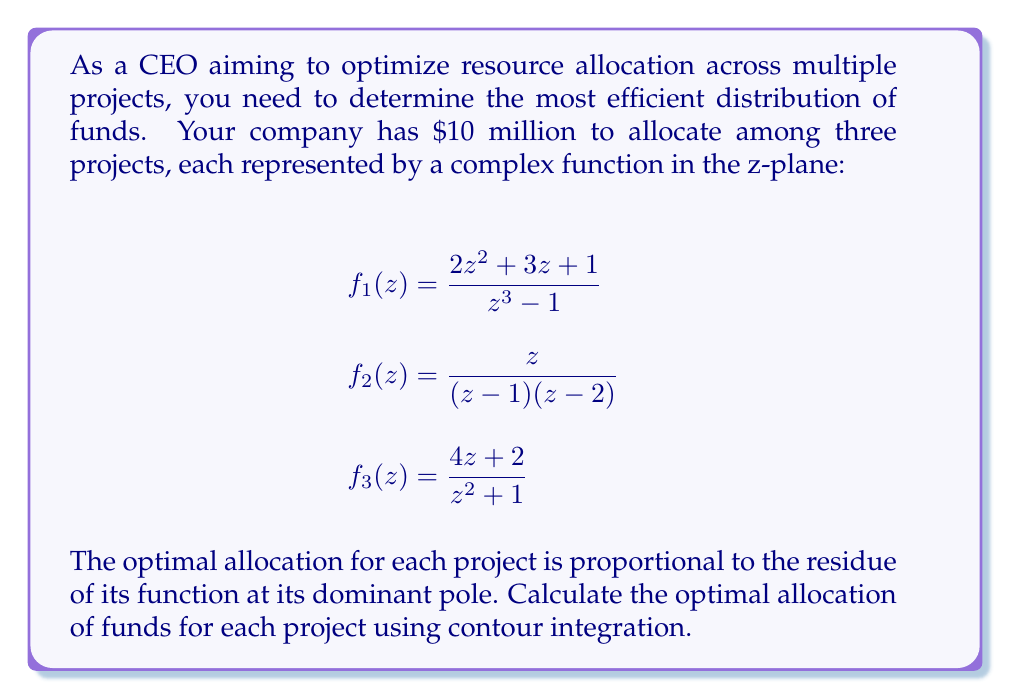Could you help me with this problem? To solve this problem, we'll use the Residue Theorem from complex analysis. The steps are as follows:

1) First, identify the poles for each function:

   $f_1(z)$: Poles at $z = 1, e^{2\pi i/3}, e^{4\pi i/3}$
   $f_2(z)$: Poles at $z = 1$ and $z = 2$
   $f_3(z)$: Poles at $z = i$ and $z = -i$

2) Calculate the residues at each pole:

   For $f_1(z)$:
   $$\text{Res}(f_1, 1) = \lim_{z \to 1} (z-1)f_1(z) = \frac{2(1)^2 + 3(1) + 1}{3(1)^2} = 2$$
   The other poles have smaller residues, so we'll focus on this one.

   For $f_2(z)$:
   $$\text{Res}(f_2, 1) = \lim_{z \to 1} (z-1)f_2(z) = \frac{1}{1-2} = -1$$
   $$\text{Res}(f_2, 2) = \lim_{z \to 2} (z-2)f_2(z) = \frac{2}{2-1} = 2$$
   The dominant pole is at $z = 2$.

   For $f_3(z)$:
   $$\text{Res}(f_3, i) = \lim_{z \to i} (z-i)f_3(z) = \frac{4i + 2}{2i} = 2 - i$$
   $$\text{Res}(f_3, -i) = \lim_{z \to -i} (z+i)f_3(z) = \frac{-4i + 2}{-2i} = 2 + i$$
   Both poles have the same magnitude, so we can choose either.

3) The optimal allocation is proportional to the magnitude of these residues:

   $|f_1|: |f_2|: |f_3| = 2 : 2 : \sqrt{5}$

4) To get the actual allocation, we normalize these values:

   Total = $2 + 2 + \sqrt{5} \approx 6.236$

   Project 1: $\frac{2}{6.236} \approx 0.321$ or 32.1%
   Project 2: $\frac{2}{6.236} \approx 0.321$ or 32.1%
   Project 3: $\frac{\sqrt{5}}{6.236} \approx 0.358$ or 35.8%

5) Finally, we multiply these percentages by the total budget:

   Project 1: $0.321 * \$10\text{M} = \$3.21\text{M}$
   Project 2: $0.321 * \$10\text{M} = \$3.21\text{M}$
   Project 3: $0.358 * \$10\text{M} = \$3.58\text{M}$
Answer: The optimal resource allocation is:
Project 1: $\$3.21$ million
Project 2: $\$3.21$ million
Project 3: $\$3.58$ million 